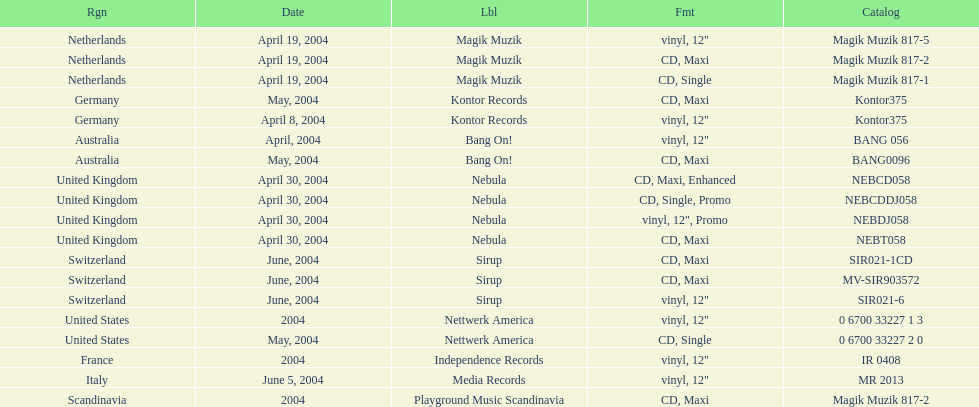What zone was mentioned on the sirup's tag? Switzerland. 